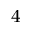Convert formula to latex. <formula><loc_0><loc_0><loc_500><loc_500>_ { 4 }</formula> 